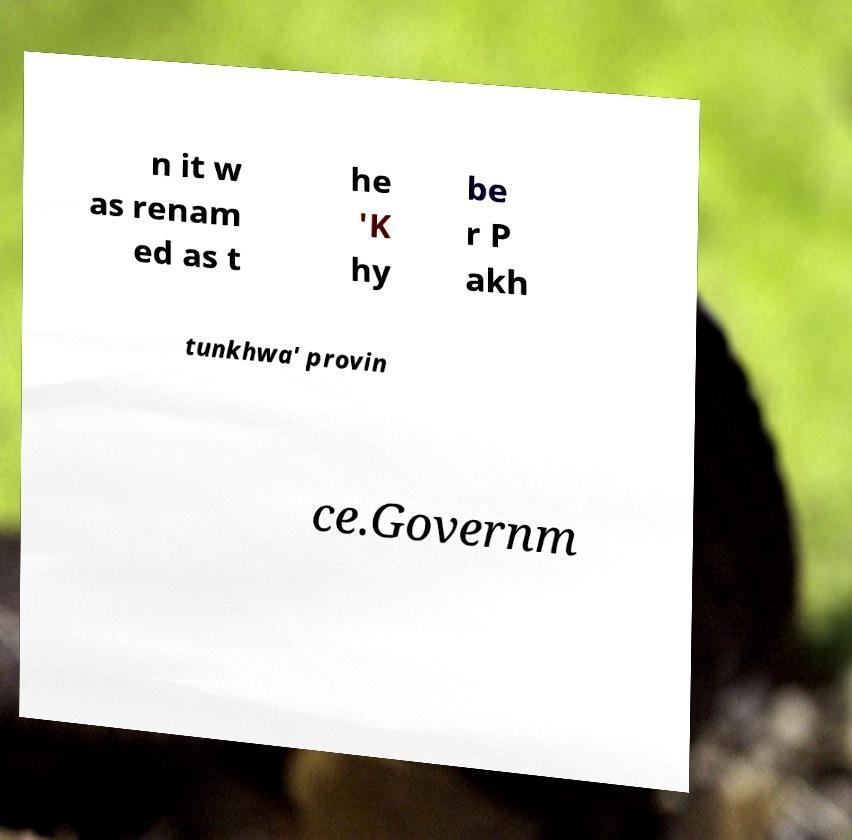Please identify and transcribe the text found in this image. n it w as renam ed as t he 'K hy be r P akh tunkhwa' provin ce.Governm 